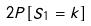Convert formula to latex. <formula><loc_0><loc_0><loc_500><loc_500>2 P [ S _ { 1 } = k ]</formula> 